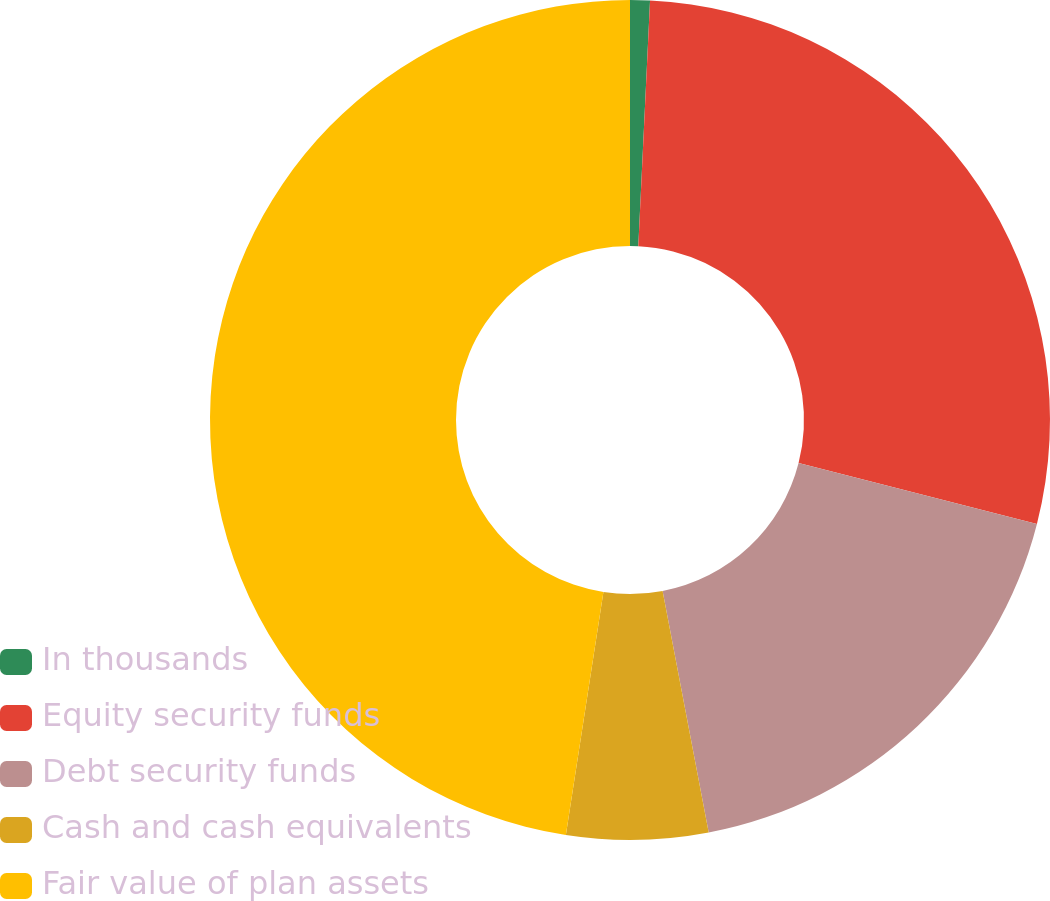Convert chart to OTSL. <chart><loc_0><loc_0><loc_500><loc_500><pie_chart><fcel>In thousands<fcel>Equity security funds<fcel>Debt security funds<fcel>Cash and cash equivalents<fcel>Fair value of plan assets<nl><fcel>0.76%<fcel>28.22%<fcel>18.02%<fcel>5.44%<fcel>47.56%<nl></chart> 